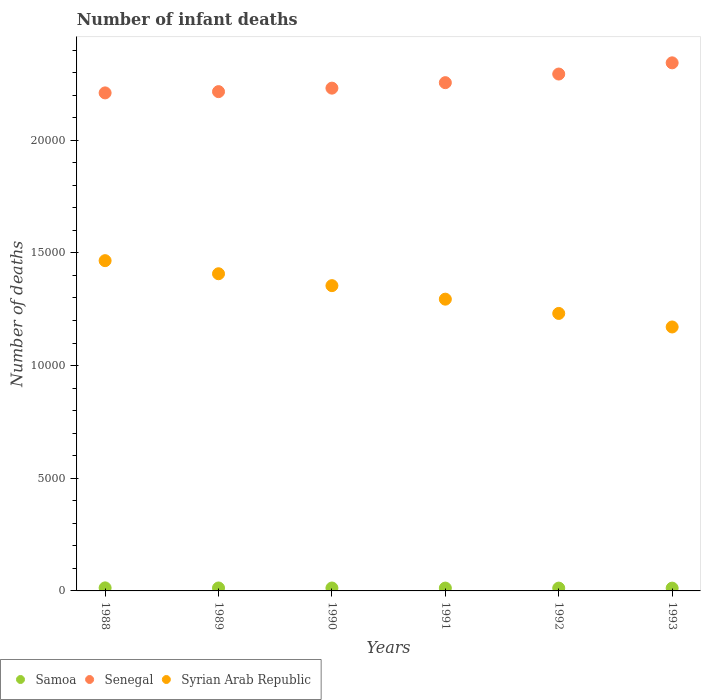Is the number of dotlines equal to the number of legend labels?
Provide a short and direct response. Yes. What is the number of infant deaths in Samoa in 1993?
Offer a very short reply. 124. Across all years, what is the maximum number of infant deaths in Samoa?
Offer a terse response. 135. Across all years, what is the minimum number of infant deaths in Syrian Arab Republic?
Offer a very short reply. 1.17e+04. In which year was the number of infant deaths in Samoa minimum?
Make the answer very short. 1993. What is the total number of infant deaths in Syrian Arab Republic in the graph?
Keep it short and to the point. 7.93e+04. What is the difference between the number of infant deaths in Senegal in 1989 and that in 1992?
Offer a very short reply. -781. What is the difference between the number of infant deaths in Samoa in 1988 and the number of infant deaths in Syrian Arab Republic in 1992?
Make the answer very short. -1.22e+04. What is the average number of infant deaths in Samoa per year?
Offer a terse response. 128.33. In the year 1993, what is the difference between the number of infant deaths in Senegal and number of infant deaths in Syrian Arab Republic?
Offer a very short reply. 1.17e+04. What is the ratio of the number of infant deaths in Samoa in 1988 to that in 1991?
Your response must be concise. 1.07. Is the difference between the number of infant deaths in Senegal in 1988 and 1991 greater than the difference between the number of infant deaths in Syrian Arab Republic in 1988 and 1991?
Provide a short and direct response. No. What is the difference between the highest and the second highest number of infant deaths in Senegal?
Make the answer very short. 497. What is the difference between the highest and the lowest number of infant deaths in Senegal?
Make the answer very short. 1334. Is the sum of the number of infant deaths in Syrian Arab Republic in 1989 and 1991 greater than the maximum number of infant deaths in Samoa across all years?
Your answer should be very brief. Yes. Does the number of infant deaths in Senegal monotonically increase over the years?
Give a very brief answer. Yes. Is the number of infant deaths in Syrian Arab Republic strictly less than the number of infant deaths in Senegal over the years?
Your answer should be compact. Yes. How many dotlines are there?
Provide a succinct answer. 3. What is the difference between two consecutive major ticks on the Y-axis?
Offer a very short reply. 5000. Does the graph contain grids?
Your answer should be compact. No. How are the legend labels stacked?
Provide a succinct answer. Horizontal. What is the title of the graph?
Provide a succinct answer. Number of infant deaths. Does "Tajikistan" appear as one of the legend labels in the graph?
Your answer should be compact. No. What is the label or title of the X-axis?
Your answer should be compact. Years. What is the label or title of the Y-axis?
Your response must be concise. Number of deaths. What is the Number of deaths of Samoa in 1988?
Make the answer very short. 135. What is the Number of deaths in Senegal in 1988?
Give a very brief answer. 2.21e+04. What is the Number of deaths of Syrian Arab Republic in 1988?
Make the answer very short. 1.47e+04. What is the Number of deaths of Samoa in 1989?
Your answer should be compact. 131. What is the Number of deaths of Senegal in 1989?
Make the answer very short. 2.22e+04. What is the Number of deaths in Syrian Arab Republic in 1989?
Your answer should be compact. 1.41e+04. What is the Number of deaths in Samoa in 1990?
Offer a terse response. 129. What is the Number of deaths in Senegal in 1990?
Provide a succinct answer. 2.23e+04. What is the Number of deaths of Syrian Arab Republic in 1990?
Your answer should be compact. 1.35e+04. What is the Number of deaths in Samoa in 1991?
Your answer should be compact. 126. What is the Number of deaths of Senegal in 1991?
Make the answer very short. 2.26e+04. What is the Number of deaths of Syrian Arab Republic in 1991?
Provide a short and direct response. 1.29e+04. What is the Number of deaths in Samoa in 1992?
Provide a succinct answer. 125. What is the Number of deaths of Senegal in 1992?
Your answer should be compact. 2.29e+04. What is the Number of deaths in Syrian Arab Republic in 1992?
Keep it short and to the point. 1.23e+04. What is the Number of deaths of Samoa in 1993?
Make the answer very short. 124. What is the Number of deaths of Senegal in 1993?
Ensure brevity in your answer.  2.34e+04. What is the Number of deaths of Syrian Arab Republic in 1993?
Keep it short and to the point. 1.17e+04. Across all years, what is the maximum Number of deaths of Samoa?
Ensure brevity in your answer.  135. Across all years, what is the maximum Number of deaths of Senegal?
Offer a very short reply. 2.34e+04. Across all years, what is the maximum Number of deaths of Syrian Arab Republic?
Offer a very short reply. 1.47e+04. Across all years, what is the minimum Number of deaths of Samoa?
Make the answer very short. 124. Across all years, what is the minimum Number of deaths of Senegal?
Your answer should be compact. 2.21e+04. Across all years, what is the minimum Number of deaths of Syrian Arab Republic?
Provide a succinct answer. 1.17e+04. What is the total Number of deaths of Samoa in the graph?
Your answer should be very brief. 770. What is the total Number of deaths of Senegal in the graph?
Your answer should be compact. 1.36e+05. What is the total Number of deaths in Syrian Arab Republic in the graph?
Your answer should be very brief. 7.93e+04. What is the difference between the Number of deaths in Samoa in 1988 and that in 1989?
Provide a succinct answer. 4. What is the difference between the Number of deaths in Senegal in 1988 and that in 1989?
Ensure brevity in your answer.  -56. What is the difference between the Number of deaths in Syrian Arab Republic in 1988 and that in 1989?
Keep it short and to the point. 581. What is the difference between the Number of deaths of Samoa in 1988 and that in 1990?
Offer a terse response. 6. What is the difference between the Number of deaths in Senegal in 1988 and that in 1990?
Provide a short and direct response. -211. What is the difference between the Number of deaths of Syrian Arab Republic in 1988 and that in 1990?
Make the answer very short. 1109. What is the difference between the Number of deaths in Samoa in 1988 and that in 1991?
Give a very brief answer. 9. What is the difference between the Number of deaths in Senegal in 1988 and that in 1991?
Offer a very short reply. -454. What is the difference between the Number of deaths in Syrian Arab Republic in 1988 and that in 1991?
Provide a short and direct response. 1709. What is the difference between the Number of deaths in Senegal in 1988 and that in 1992?
Provide a succinct answer. -837. What is the difference between the Number of deaths in Syrian Arab Republic in 1988 and that in 1992?
Give a very brief answer. 2342. What is the difference between the Number of deaths in Senegal in 1988 and that in 1993?
Your answer should be very brief. -1334. What is the difference between the Number of deaths of Syrian Arab Republic in 1988 and that in 1993?
Offer a terse response. 2943. What is the difference between the Number of deaths in Samoa in 1989 and that in 1990?
Offer a very short reply. 2. What is the difference between the Number of deaths of Senegal in 1989 and that in 1990?
Offer a very short reply. -155. What is the difference between the Number of deaths in Syrian Arab Republic in 1989 and that in 1990?
Your answer should be compact. 528. What is the difference between the Number of deaths in Senegal in 1989 and that in 1991?
Offer a very short reply. -398. What is the difference between the Number of deaths in Syrian Arab Republic in 1989 and that in 1991?
Your answer should be compact. 1128. What is the difference between the Number of deaths in Senegal in 1989 and that in 1992?
Provide a short and direct response. -781. What is the difference between the Number of deaths of Syrian Arab Republic in 1989 and that in 1992?
Offer a terse response. 1761. What is the difference between the Number of deaths of Samoa in 1989 and that in 1993?
Offer a very short reply. 7. What is the difference between the Number of deaths of Senegal in 1989 and that in 1993?
Ensure brevity in your answer.  -1278. What is the difference between the Number of deaths in Syrian Arab Republic in 1989 and that in 1993?
Keep it short and to the point. 2362. What is the difference between the Number of deaths in Senegal in 1990 and that in 1991?
Provide a succinct answer. -243. What is the difference between the Number of deaths of Syrian Arab Republic in 1990 and that in 1991?
Keep it short and to the point. 600. What is the difference between the Number of deaths in Senegal in 1990 and that in 1992?
Ensure brevity in your answer.  -626. What is the difference between the Number of deaths of Syrian Arab Republic in 1990 and that in 1992?
Provide a succinct answer. 1233. What is the difference between the Number of deaths of Samoa in 1990 and that in 1993?
Provide a succinct answer. 5. What is the difference between the Number of deaths in Senegal in 1990 and that in 1993?
Provide a short and direct response. -1123. What is the difference between the Number of deaths of Syrian Arab Republic in 1990 and that in 1993?
Your answer should be very brief. 1834. What is the difference between the Number of deaths in Senegal in 1991 and that in 1992?
Keep it short and to the point. -383. What is the difference between the Number of deaths of Syrian Arab Republic in 1991 and that in 1992?
Your response must be concise. 633. What is the difference between the Number of deaths of Samoa in 1991 and that in 1993?
Provide a succinct answer. 2. What is the difference between the Number of deaths of Senegal in 1991 and that in 1993?
Provide a short and direct response. -880. What is the difference between the Number of deaths of Syrian Arab Republic in 1991 and that in 1993?
Provide a succinct answer. 1234. What is the difference between the Number of deaths in Samoa in 1992 and that in 1993?
Give a very brief answer. 1. What is the difference between the Number of deaths of Senegal in 1992 and that in 1993?
Your answer should be compact. -497. What is the difference between the Number of deaths of Syrian Arab Republic in 1992 and that in 1993?
Offer a very short reply. 601. What is the difference between the Number of deaths of Samoa in 1988 and the Number of deaths of Senegal in 1989?
Your answer should be compact. -2.20e+04. What is the difference between the Number of deaths of Samoa in 1988 and the Number of deaths of Syrian Arab Republic in 1989?
Your answer should be compact. -1.39e+04. What is the difference between the Number of deaths in Senegal in 1988 and the Number of deaths in Syrian Arab Republic in 1989?
Give a very brief answer. 8026. What is the difference between the Number of deaths of Samoa in 1988 and the Number of deaths of Senegal in 1990?
Your answer should be very brief. -2.22e+04. What is the difference between the Number of deaths of Samoa in 1988 and the Number of deaths of Syrian Arab Republic in 1990?
Make the answer very short. -1.34e+04. What is the difference between the Number of deaths of Senegal in 1988 and the Number of deaths of Syrian Arab Republic in 1990?
Provide a succinct answer. 8554. What is the difference between the Number of deaths in Samoa in 1988 and the Number of deaths in Senegal in 1991?
Offer a terse response. -2.24e+04. What is the difference between the Number of deaths in Samoa in 1988 and the Number of deaths in Syrian Arab Republic in 1991?
Provide a succinct answer. -1.28e+04. What is the difference between the Number of deaths in Senegal in 1988 and the Number of deaths in Syrian Arab Republic in 1991?
Make the answer very short. 9154. What is the difference between the Number of deaths in Samoa in 1988 and the Number of deaths in Senegal in 1992?
Give a very brief answer. -2.28e+04. What is the difference between the Number of deaths in Samoa in 1988 and the Number of deaths in Syrian Arab Republic in 1992?
Your answer should be compact. -1.22e+04. What is the difference between the Number of deaths of Senegal in 1988 and the Number of deaths of Syrian Arab Republic in 1992?
Provide a short and direct response. 9787. What is the difference between the Number of deaths in Samoa in 1988 and the Number of deaths in Senegal in 1993?
Your response must be concise. -2.33e+04. What is the difference between the Number of deaths in Samoa in 1988 and the Number of deaths in Syrian Arab Republic in 1993?
Ensure brevity in your answer.  -1.16e+04. What is the difference between the Number of deaths in Senegal in 1988 and the Number of deaths in Syrian Arab Republic in 1993?
Provide a short and direct response. 1.04e+04. What is the difference between the Number of deaths of Samoa in 1989 and the Number of deaths of Senegal in 1990?
Your answer should be compact. -2.22e+04. What is the difference between the Number of deaths in Samoa in 1989 and the Number of deaths in Syrian Arab Republic in 1990?
Your answer should be very brief. -1.34e+04. What is the difference between the Number of deaths of Senegal in 1989 and the Number of deaths of Syrian Arab Republic in 1990?
Keep it short and to the point. 8610. What is the difference between the Number of deaths in Samoa in 1989 and the Number of deaths in Senegal in 1991?
Offer a very short reply. -2.24e+04. What is the difference between the Number of deaths of Samoa in 1989 and the Number of deaths of Syrian Arab Republic in 1991?
Offer a terse response. -1.28e+04. What is the difference between the Number of deaths of Senegal in 1989 and the Number of deaths of Syrian Arab Republic in 1991?
Provide a short and direct response. 9210. What is the difference between the Number of deaths of Samoa in 1989 and the Number of deaths of Senegal in 1992?
Provide a succinct answer. -2.28e+04. What is the difference between the Number of deaths in Samoa in 1989 and the Number of deaths in Syrian Arab Republic in 1992?
Your answer should be very brief. -1.22e+04. What is the difference between the Number of deaths of Senegal in 1989 and the Number of deaths of Syrian Arab Republic in 1992?
Keep it short and to the point. 9843. What is the difference between the Number of deaths in Samoa in 1989 and the Number of deaths in Senegal in 1993?
Your response must be concise. -2.33e+04. What is the difference between the Number of deaths of Samoa in 1989 and the Number of deaths of Syrian Arab Republic in 1993?
Offer a terse response. -1.16e+04. What is the difference between the Number of deaths of Senegal in 1989 and the Number of deaths of Syrian Arab Republic in 1993?
Ensure brevity in your answer.  1.04e+04. What is the difference between the Number of deaths in Samoa in 1990 and the Number of deaths in Senegal in 1991?
Provide a short and direct response. -2.24e+04. What is the difference between the Number of deaths of Samoa in 1990 and the Number of deaths of Syrian Arab Republic in 1991?
Provide a short and direct response. -1.28e+04. What is the difference between the Number of deaths in Senegal in 1990 and the Number of deaths in Syrian Arab Republic in 1991?
Offer a terse response. 9365. What is the difference between the Number of deaths of Samoa in 1990 and the Number of deaths of Senegal in 1992?
Make the answer very short. -2.28e+04. What is the difference between the Number of deaths in Samoa in 1990 and the Number of deaths in Syrian Arab Republic in 1992?
Your response must be concise. -1.22e+04. What is the difference between the Number of deaths of Senegal in 1990 and the Number of deaths of Syrian Arab Republic in 1992?
Your response must be concise. 9998. What is the difference between the Number of deaths in Samoa in 1990 and the Number of deaths in Senegal in 1993?
Your answer should be very brief. -2.33e+04. What is the difference between the Number of deaths of Samoa in 1990 and the Number of deaths of Syrian Arab Republic in 1993?
Keep it short and to the point. -1.16e+04. What is the difference between the Number of deaths in Senegal in 1990 and the Number of deaths in Syrian Arab Republic in 1993?
Your answer should be very brief. 1.06e+04. What is the difference between the Number of deaths in Samoa in 1991 and the Number of deaths in Senegal in 1992?
Your response must be concise. -2.28e+04. What is the difference between the Number of deaths in Samoa in 1991 and the Number of deaths in Syrian Arab Republic in 1992?
Ensure brevity in your answer.  -1.22e+04. What is the difference between the Number of deaths in Senegal in 1991 and the Number of deaths in Syrian Arab Republic in 1992?
Offer a very short reply. 1.02e+04. What is the difference between the Number of deaths in Samoa in 1991 and the Number of deaths in Senegal in 1993?
Your answer should be very brief. -2.33e+04. What is the difference between the Number of deaths of Samoa in 1991 and the Number of deaths of Syrian Arab Republic in 1993?
Give a very brief answer. -1.16e+04. What is the difference between the Number of deaths in Senegal in 1991 and the Number of deaths in Syrian Arab Republic in 1993?
Ensure brevity in your answer.  1.08e+04. What is the difference between the Number of deaths in Samoa in 1992 and the Number of deaths in Senegal in 1993?
Provide a succinct answer. -2.33e+04. What is the difference between the Number of deaths in Samoa in 1992 and the Number of deaths in Syrian Arab Republic in 1993?
Ensure brevity in your answer.  -1.16e+04. What is the difference between the Number of deaths in Senegal in 1992 and the Number of deaths in Syrian Arab Republic in 1993?
Ensure brevity in your answer.  1.12e+04. What is the average Number of deaths of Samoa per year?
Your answer should be compact. 128.33. What is the average Number of deaths of Senegal per year?
Your answer should be compact. 2.26e+04. What is the average Number of deaths in Syrian Arab Republic per year?
Offer a terse response. 1.32e+04. In the year 1988, what is the difference between the Number of deaths of Samoa and Number of deaths of Senegal?
Make the answer very short. -2.20e+04. In the year 1988, what is the difference between the Number of deaths in Samoa and Number of deaths in Syrian Arab Republic?
Give a very brief answer. -1.45e+04. In the year 1988, what is the difference between the Number of deaths in Senegal and Number of deaths in Syrian Arab Republic?
Provide a short and direct response. 7445. In the year 1989, what is the difference between the Number of deaths of Samoa and Number of deaths of Senegal?
Provide a succinct answer. -2.20e+04. In the year 1989, what is the difference between the Number of deaths of Samoa and Number of deaths of Syrian Arab Republic?
Provide a succinct answer. -1.39e+04. In the year 1989, what is the difference between the Number of deaths in Senegal and Number of deaths in Syrian Arab Republic?
Your response must be concise. 8082. In the year 1990, what is the difference between the Number of deaths in Samoa and Number of deaths in Senegal?
Your answer should be very brief. -2.22e+04. In the year 1990, what is the difference between the Number of deaths of Samoa and Number of deaths of Syrian Arab Republic?
Provide a short and direct response. -1.34e+04. In the year 1990, what is the difference between the Number of deaths in Senegal and Number of deaths in Syrian Arab Republic?
Keep it short and to the point. 8765. In the year 1991, what is the difference between the Number of deaths in Samoa and Number of deaths in Senegal?
Your answer should be very brief. -2.24e+04. In the year 1991, what is the difference between the Number of deaths of Samoa and Number of deaths of Syrian Arab Republic?
Your response must be concise. -1.28e+04. In the year 1991, what is the difference between the Number of deaths in Senegal and Number of deaths in Syrian Arab Republic?
Provide a short and direct response. 9608. In the year 1992, what is the difference between the Number of deaths in Samoa and Number of deaths in Senegal?
Make the answer very short. -2.28e+04. In the year 1992, what is the difference between the Number of deaths of Samoa and Number of deaths of Syrian Arab Republic?
Offer a very short reply. -1.22e+04. In the year 1992, what is the difference between the Number of deaths of Senegal and Number of deaths of Syrian Arab Republic?
Offer a terse response. 1.06e+04. In the year 1993, what is the difference between the Number of deaths of Samoa and Number of deaths of Senegal?
Provide a short and direct response. -2.33e+04. In the year 1993, what is the difference between the Number of deaths in Samoa and Number of deaths in Syrian Arab Republic?
Make the answer very short. -1.16e+04. In the year 1993, what is the difference between the Number of deaths of Senegal and Number of deaths of Syrian Arab Republic?
Your answer should be very brief. 1.17e+04. What is the ratio of the Number of deaths of Samoa in 1988 to that in 1989?
Ensure brevity in your answer.  1.03. What is the ratio of the Number of deaths in Syrian Arab Republic in 1988 to that in 1989?
Give a very brief answer. 1.04. What is the ratio of the Number of deaths of Samoa in 1988 to that in 1990?
Give a very brief answer. 1.05. What is the ratio of the Number of deaths in Senegal in 1988 to that in 1990?
Your answer should be very brief. 0.99. What is the ratio of the Number of deaths in Syrian Arab Republic in 1988 to that in 1990?
Keep it short and to the point. 1.08. What is the ratio of the Number of deaths in Samoa in 1988 to that in 1991?
Ensure brevity in your answer.  1.07. What is the ratio of the Number of deaths of Senegal in 1988 to that in 1991?
Offer a very short reply. 0.98. What is the ratio of the Number of deaths of Syrian Arab Republic in 1988 to that in 1991?
Give a very brief answer. 1.13. What is the ratio of the Number of deaths in Senegal in 1988 to that in 1992?
Give a very brief answer. 0.96. What is the ratio of the Number of deaths in Syrian Arab Republic in 1988 to that in 1992?
Make the answer very short. 1.19. What is the ratio of the Number of deaths in Samoa in 1988 to that in 1993?
Provide a short and direct response. 1.09. What is the ratio of the Number of deaths in Senegal in 1988 to that in 1993?
Your response must be concise. 0.94. What is the ratio of the Number of deaths of Syrian Arab Republic in 1988 to that in 1993?
Your response must be concise. 1.25. What is the ratio of the Number of deaths of Samoa in 1989 to that in 1990?
Your answer should be very brief. 1.02. What is the ratio of the Number of deaths of Senegal in 1989 to that in 1990?
Give a very brief answer. 0.99. What is the ratio of the Number of deaths in Syrian Arab Republic in 1989 to that in 1990?
Give a very brief answer. 1.04. What is the ratio of the Number of deaths in Samoa in 1989 to that in 1991?
Ensure brevity in your answer.  1.04. What is the ratio of the Number of deaths in Senegal in 1989 to that in 1991?
Provide a short and direct response. 0.98. What is the ratio of the Number of deaths of Syrian Arab Republic in 1989 to that in 1991?
Ensure brevity in your answer.  1.09. What is the ratio of the Number of deaths of Samoa in 1989 to that in 1992?
Keep it short and to the point. 1.05. What is the ratio of the Number of deaths in Syrian Arab Republic in 1989 to that in 1992?
Your response must be concise. 1.14. What is the ratio of the Number of deaths of Samoa in 1989 to that in 1993?
Make the answer very short. 1.06. What is the ratio of the Number of deaths of Senegal in 1989 to that in 1993?
Provide a short and direct response. 0.95. What is the ratio of the Number of deaths of Syrian Arab Republic in 1989 to that in 1993?
Provide a succinct answer. 1.2. What is the ratio of the Number of deaths in Samoa in 1990 to that in 1991?
Offer a very short reply. 1.02. What is the ratio of the Number of deaths in Senegal in 1990 to that in 1991?
Make the answer very short. 0.99. What is the ratio of the Number of deaths of Syrian Arab Republic in 1990 to that in 1991?
Provide a succinct answer. 1.05. What is the ratio of the Number of deaths of Samoa in 1990 to that in 1992?
Your answer should be compact. 1.03. What is the ratio of the Number of deaths in Senegal in 1990 to that in 1992?
Keep it short and to the point. 0.97. What is the ratio of the Number of deaths of Syrian Arab Republic in 1990 to that in 1992?
Make the answer very short. 1.1. What is the ratio of the Number of deaths of Samoa in 1990 to that in 1993?
Offer a very short reply. 1.04. What is the ratio of the Number of deaths in Senegal in 1990 to that in 1993?
Ensure brevity in your answer.  0.95. What is the ratio of the Number of deaths of Syrian Arab Republic in 1990 to that in 1993?
Make the answer very short. 1.16. What is the ratio of the Number of deaths in Samoa in 1991 to that in 1992?
Your response must be concise. 1.01. What is the ratio of the Number of deaths of Senegal in 1991 to that in 1992?
Provide a short and direct response. 0.98. What is the ratio of the Number of deaths in Syrian Arab Republic in 1991 to that in 1992?
Ensure brevity in your answer.  1.05. What is the ratio of the Number of deaths of Samoa in 1991 to that in 1993?
Offer a very short reply. 1.02. What is the ratio of the Number of deaths of Senegal in 1991 to that in 1993?
Make the answer very short. 0.96. What is the ratio of the Number of deaths of Syrian Arab Republic in 1991 to that in 1993?
Make the answer very short. 1.11. What is the ratio of the Number of deaths of Senegal in 1992 to that in 1993?
Your answer should be compact. 0.98. What is the ratio of the Number of deaths of Syrian Arab Republic in 1992 to that in 1993?
Ensure brevity in your answer.  1.05. What is the difference between the highest and the second highest Number of deaths in Samoa?
Your answer should be compact. 4. What is the difference between the highest and the second highest Number of deaths of Senegal?
Provide a short and direct response. 497. What is the difference between the highest and the second highest Number of deaths in Syrian Arab Republic?
Your answer should be compact. 581. What is the difference between the highest and the lowest Number of deaths of Samoa?
Ensure brevity in your answer.  11. What is the difference between the highest and the lowest Number of deaths of Senegal?
Keep it short and to the point. 1334. What is the difference between the highest and the lowest Number of deaths of Syrian Arab Republic?
Make the answer very short. 2943. 